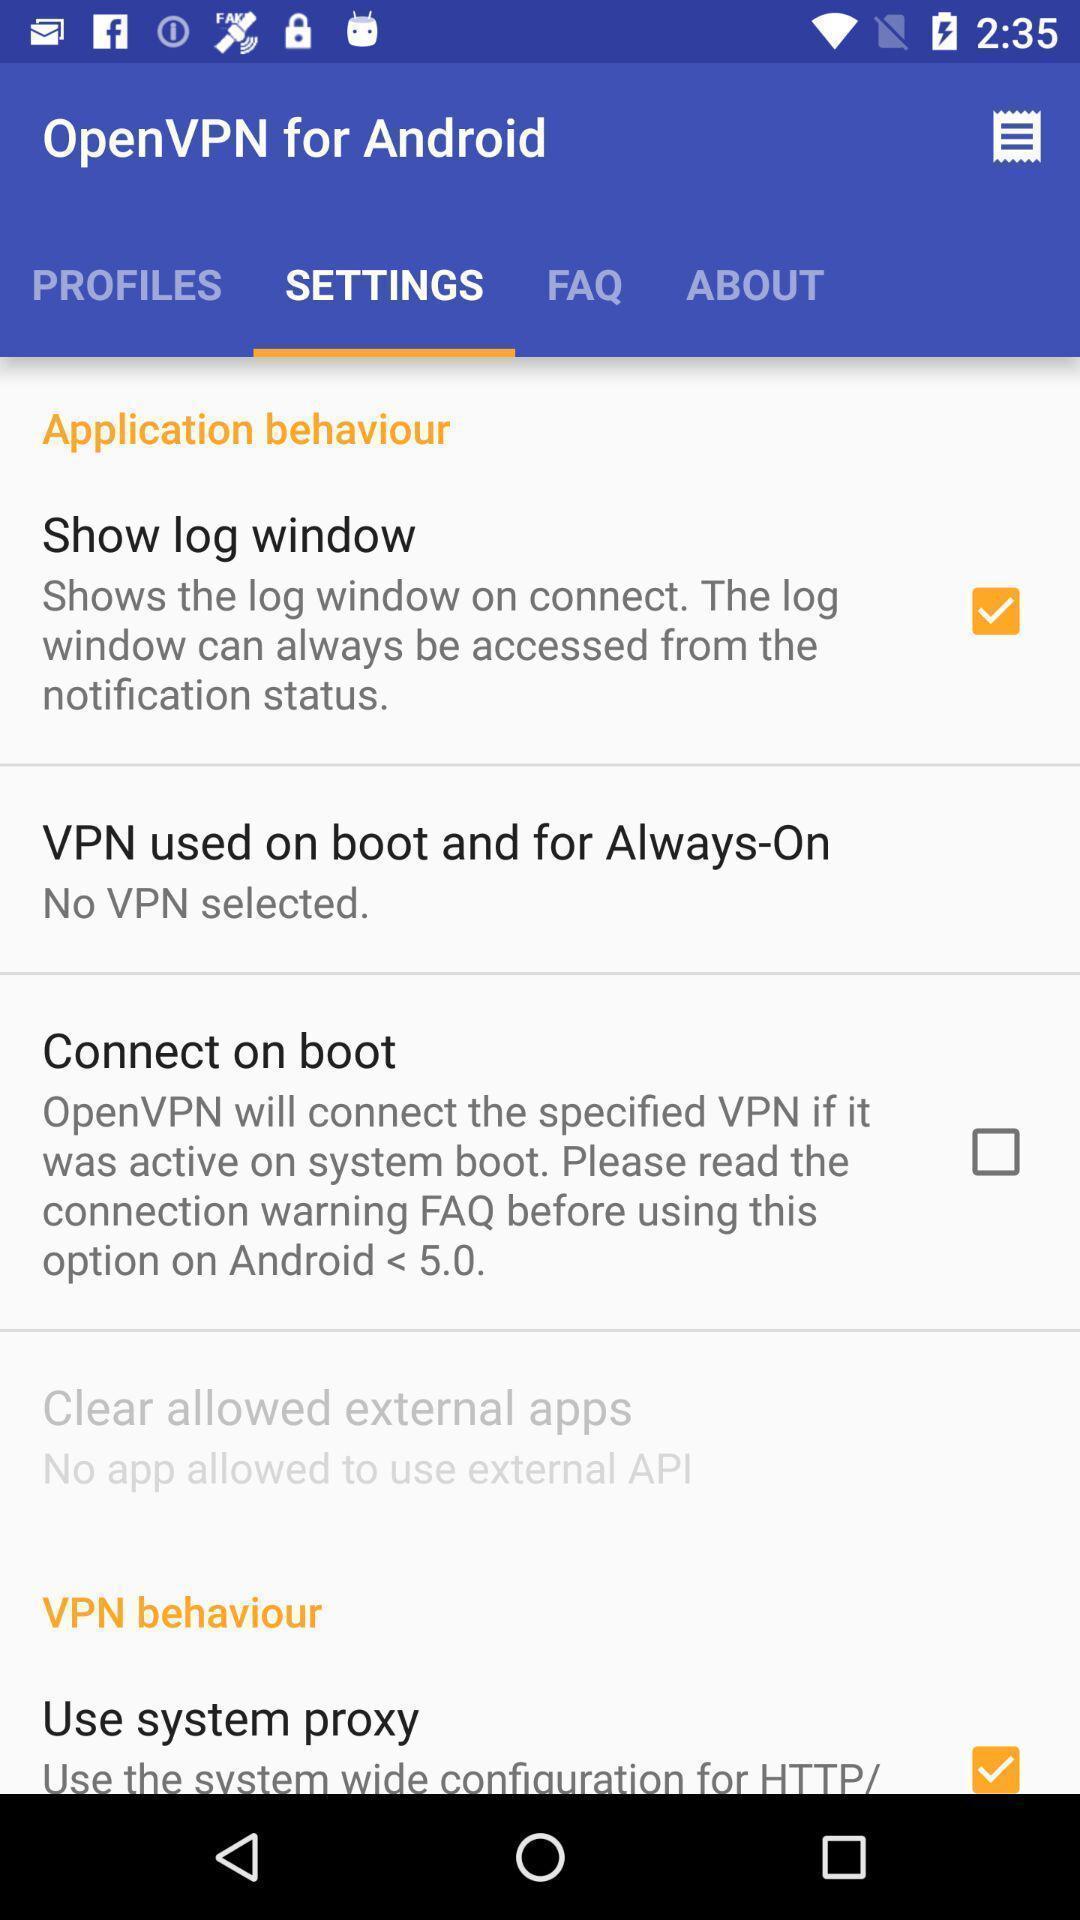Provide a detailed account of this screenshot. Page showing settings. 